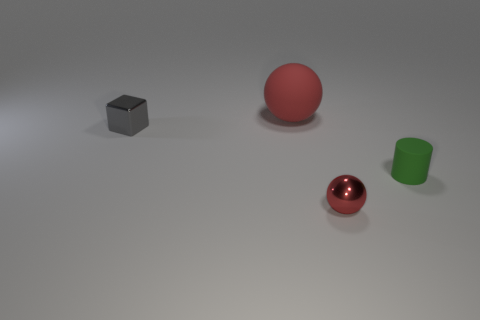Add 1 tiny rubber objects. How many objects exist? 5 Subtract all cubes. How many objects are left? 3 Subtract 0 purple spheres. How many objects are left? 4 Subtract all yellow cubes. Subtract all big rubber spheres. How many objects are left? 3 Add 2 tiny green matte objects. How many tiny green matte objects are left? 3 Add 2 small cyan shiny cylinders. How many small cyan shiny cylinders exist? 2 